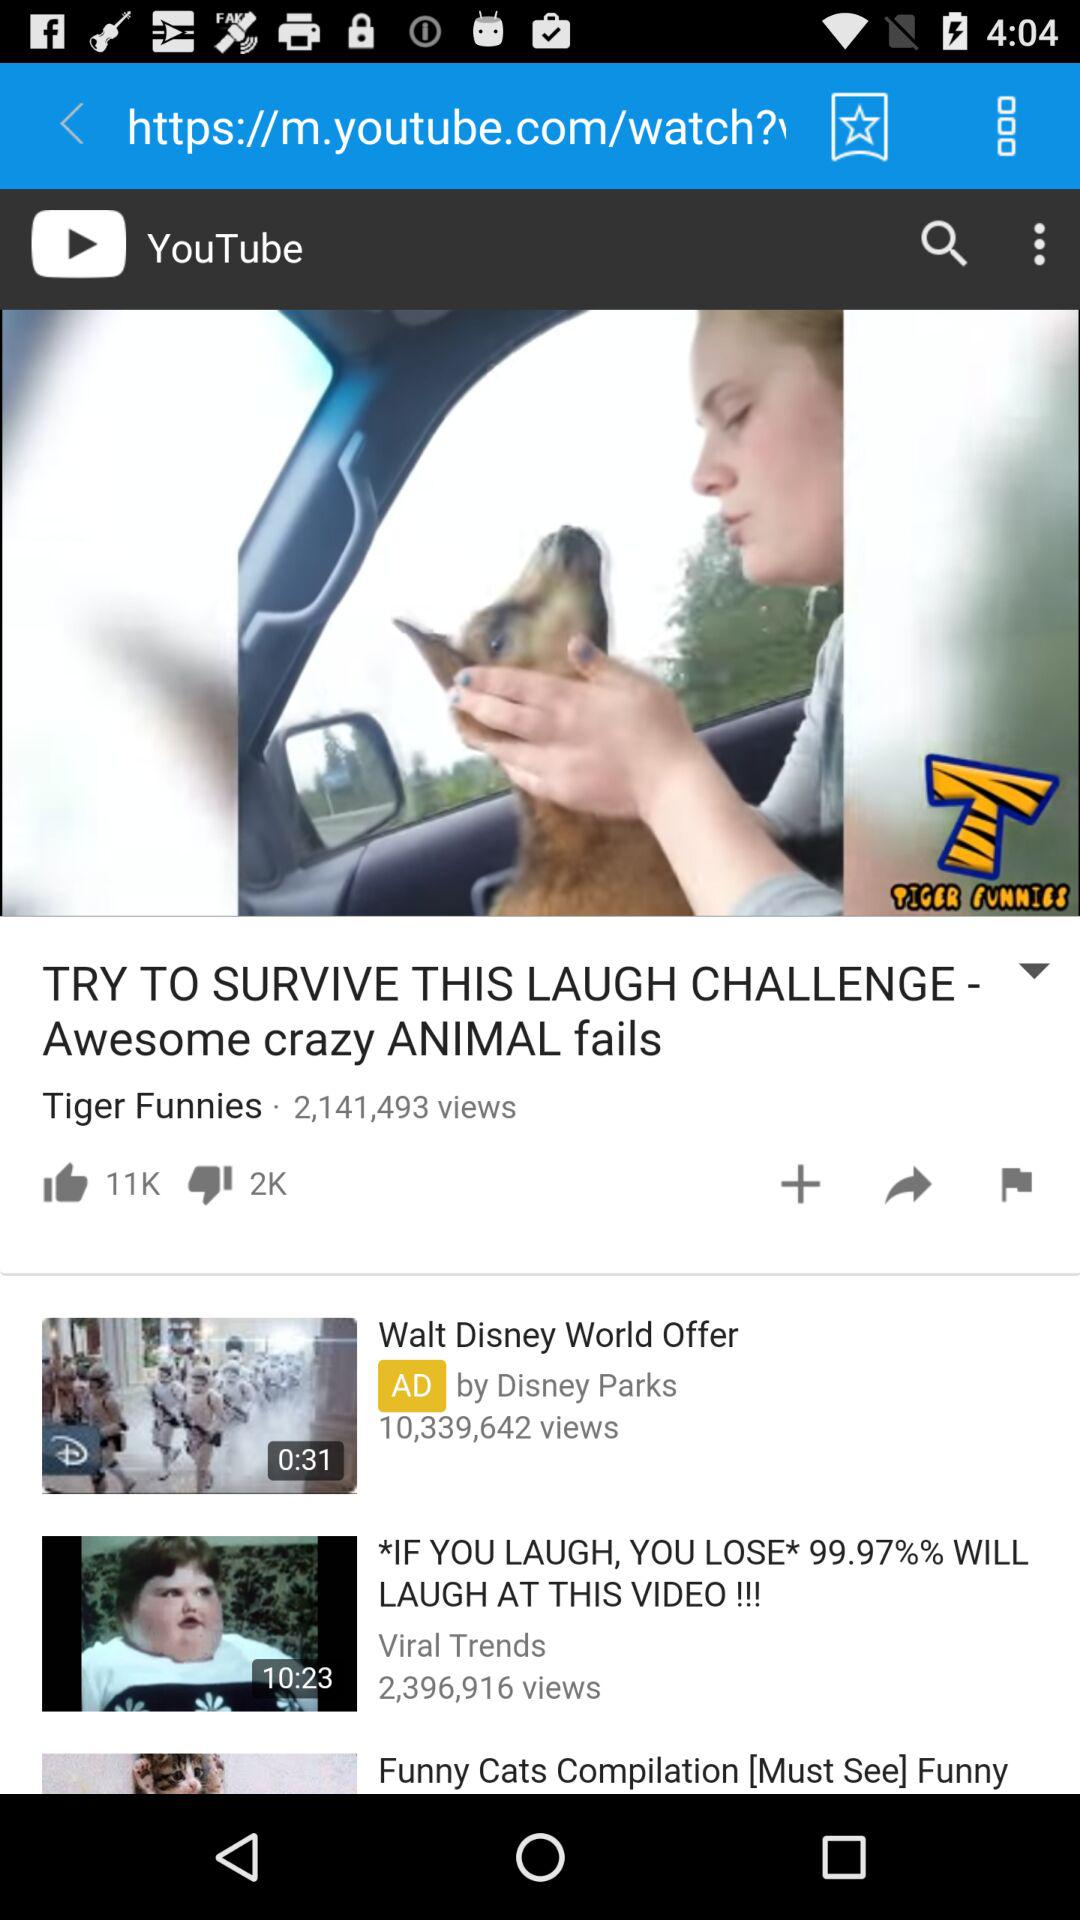What is the view count of "Walt Disney World Offer"? The view count is 10,339,642. 